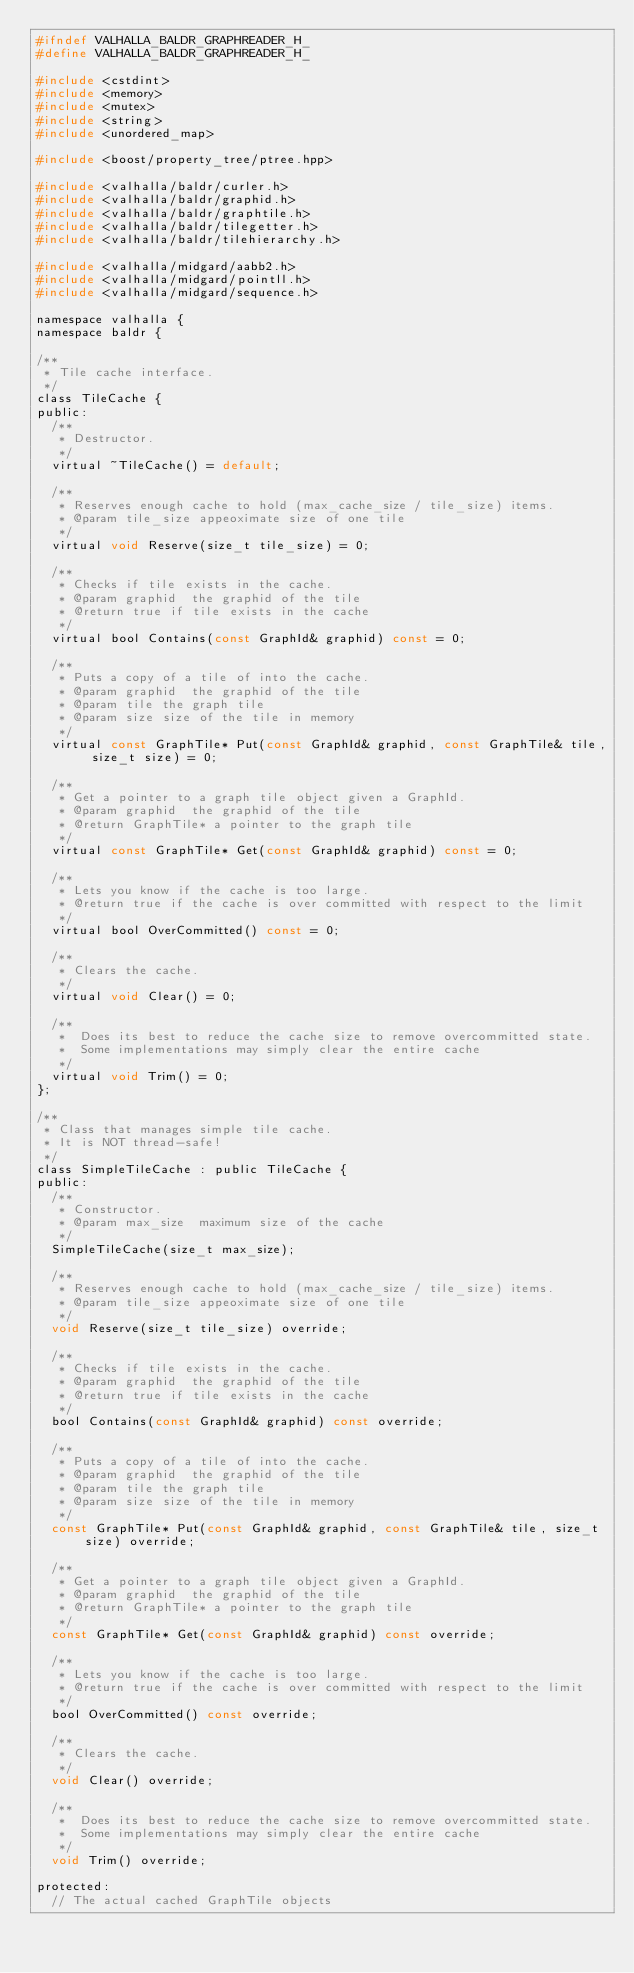Convert code to text. <code><loc_0><loc_0><loc_500><loc_500><_C_>#ifndef VALHALLA_BALDR_GRAPHREADER_H_
#define VALHALLA_BALDR_GRAPHREADER_H_

#include <cstdint>
#include <memory>
#include <mutex>
#include <string>
#include <unordered_map>

#include <boost/property_tree/ptree.hpp>

#include <valhalla/baldr/curler.h>
#include <valhalla/baldr/graphid.h>
#include <valhalla/baldr/graphtile.h>
#include <valhalla/baldr/tilegetter.h>
#include <valhalla/baldr/tilehierarchy.h>

#include <valhalla/midgard/aabb2.h>
#include <valhalla/midgard/pointll.h>
#include <valhalla/midgard/sequence.h>

namespace valhalla {
namespace baldr {

/**
 * Tile cache interface.
 */
class TileCache {
public:
  /**
   * Destructor.
   */
  virtual ~TileCache() = default;

  /**
   * Reserves enough cache to hold (max_cache_size / tile_size) items.
   * @param tile_size appeoximate size of one tile
   */
  virtual void Reserve(size_t tile_size) = 0;

  /**
   * Checks if tile exists in the cache.
   * @param graphid  the graphid of the tile
   * @return true if tile exists in the cache
   */
  virtual bool Contains(const GraphId& graphid) const = 0;

  /**
   * Puts a copy of a tile of into the cache.
   * @param graphid  the graphid of the tile
   * @param tile the graph tile
   * @param size size of the tile in memory
   */
  virtual const GraphTile* Put(const GraphId& graphid, const GraphTile& tile, size_t size) = 0;

  /**
   * Get a pointer to a graph tile object given a GraphId.
   * @param graphid  the graphid of the tile
   * @return GraphTile* a pointer to the graph tile
   */
  virtual const GraphTile* Get(const GraphId& graphid) const = 0;

  /**
   * Lets you know if the cache is too large.
   * @return true if the cache is over committed with respect to the limit
   */
  virtual bool OverCommitted() const = 0;

  /**
   * Clears the cache.
   */
  virtual void Clear() = 0;

  /**
   *  Does its best to reduce the cache size to remove overcommitted state.
   *  Some implementations may simply clear the entire cache
   */
  virtual void Trim() = 0;
};

/**
 * Class that manages simple tile cache.
 * It is NOT thread-safe!
 */
class SimpleTileCache : public TileCache {
public:
  /**
   * Constructor.
   * @param max_size  maximum size of the cache
   */
  SimpleTileCache(size_t max_size);

  /**
   * Reserves enough cache to hold (max_cache_size / tile_size) items.
   * @param tile_size appeoximate size of one tile
   */
  void Reserve(size_t tile_size) override;

  /**
   * Checks if tile exists in the cache.
   * @param graphid  the graphid of the tile
   * @return true if tile exists in the cache
   */
  bool Contains(const GraphId& graphid) const override;

  /**
   * Puts a copy of a tile of into the cache.
   * @param graphid  the graphid of the tile
   * @param tile the graph tile
   * @param size size of the tile in memory
   */
  const GraphTile* Put(const GraphId& graphid, const GraphTile& tile, size_t size) override;

  /**
   * Get a pointer to a graph tile object given a GraphId.
   * @param graphid  the graphid of the tile
   * @return GraphTile* a pointer to the graph tile
   */
  const GraphTile* Get(const GraphId& graphid) const override;

  /**
   * Lets you know if the cache is too large.
   * @return true if the cache is over committed with respect to the limit
   */
  bool OverCommitted() const override;

  /**
   * Clears the cache.
   */
  void Clear() override;

  /**
   *  Does its best to reduce the cache size to remove overcommitted state.
   *  Some implementations may simply clear the entire cache
   */
  void Trim() override;

protected:
  // The actual cached GraphTile objects</code> 